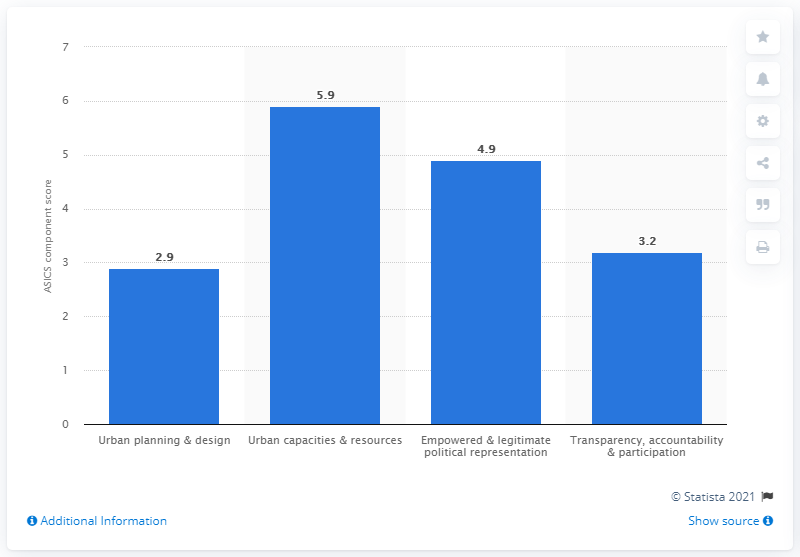Identify some key points in this picture. In 2017, Mumbai was assigned a score of 5.9 out of 10 in its urban capacities and resources. 